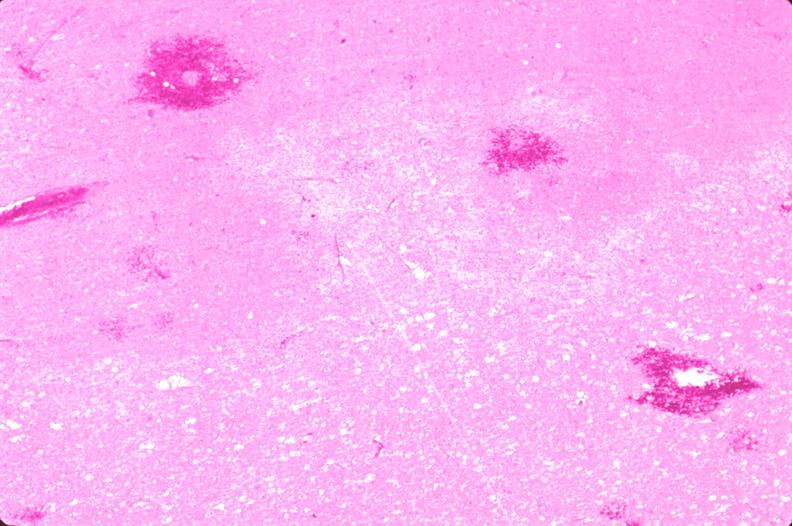does this image show brain, infarct due to ruptured saccular aneurysm and thrombosis of right middle cerebral artery?
Answer the question using a single word or phrase. Yes 